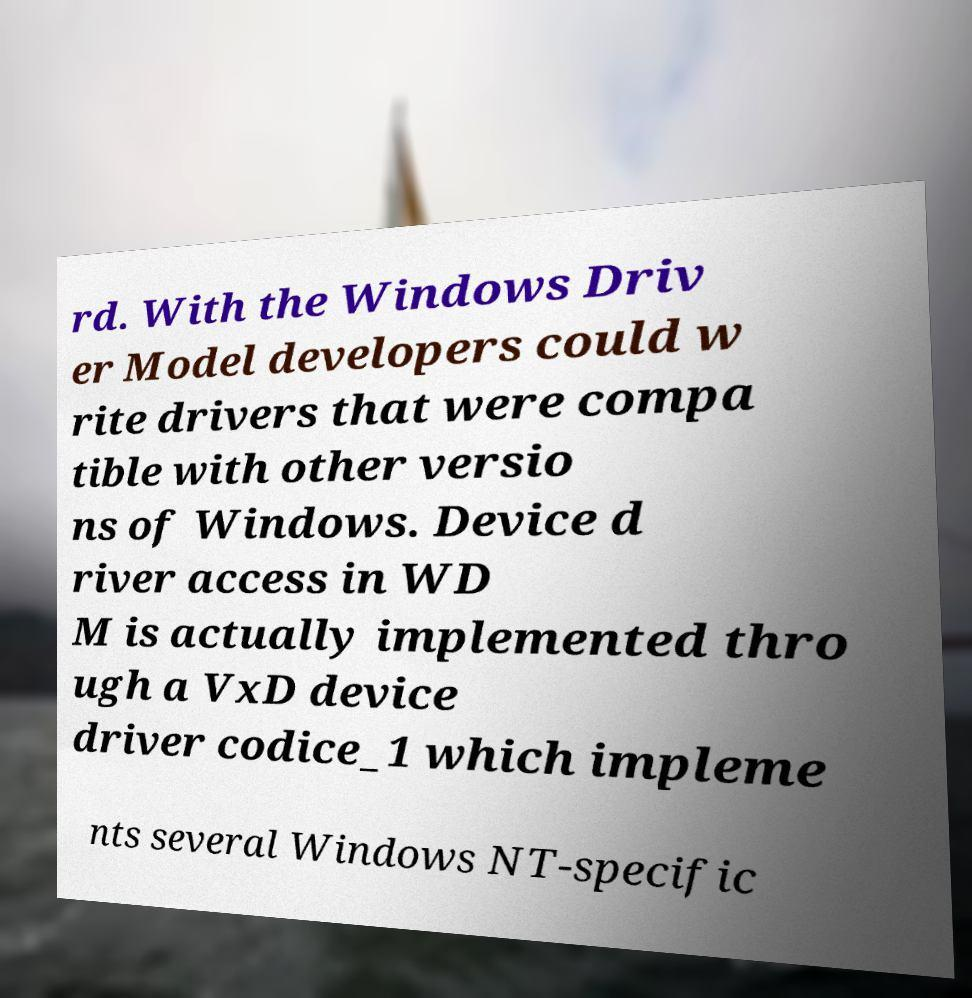Could you assist in decoding the text presented in this image and type it out clearly? rd. With the Windows Driv er Model developers could w rite drivers that were compa tible with other versio ns of Windows. Device d river access in WD M is actually implemented thro ugh a VxD device driver codice_1 which impleme nts several Windows NT-specific 